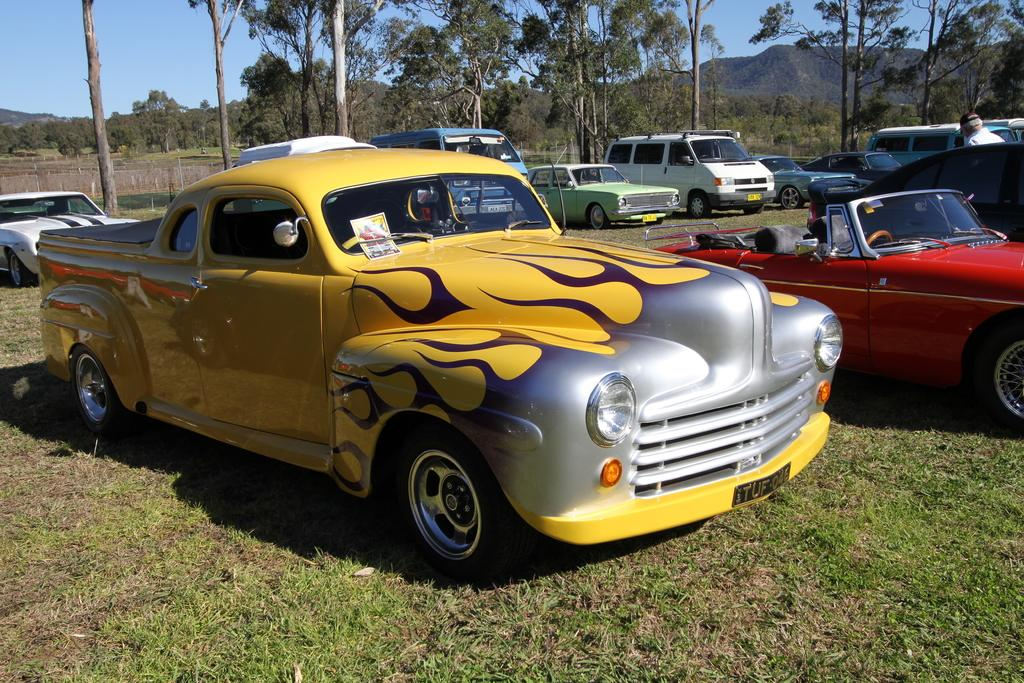What types of objects are present in the image? There are vehicles in the image. Can you describe the person in the image? There is a person on the ground in the image. What natural elements can be seen in the image? There are trees, mountains, and grass in the image. What part of the natural environment is visible in the background of the image? The sky is visible in the background of the image. What type of vegetable is being used as a handrail for the vehicles in the image? There is no vegetable being used as a handrail in the image; the vehicles are not interacting with any vegetables. 